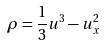Convert formula to latex. <formula><loc_0><loc_0><loc_500><loc_500>\rho = \frac { 1 } { 3 } u ^ { 3 } - u _ { x } ^ { 2 }</formula> 